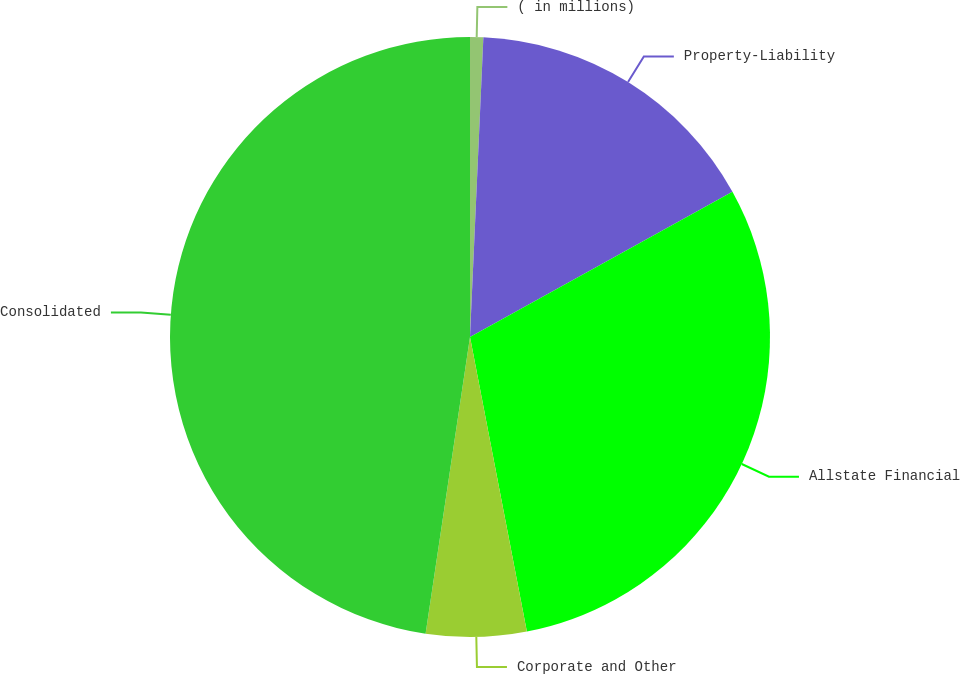Convert chart. <chart><loc_0><loc_0><loc_500><loc_500><pie_chart><fcel>( in millions)<fcel>Property-Liability<fcel>Allstate Financial<fcel>Corporate and Other<fcel>Consolidated<nl><fcel>0.71%<fcel>16.24%<fcel>30.01%<fcel>5.4%<fcel>47.63%<nl></chart> 